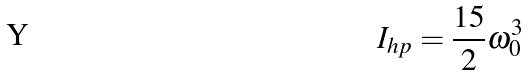Convert formula to latex. <formula><loc_0><loc_0><loc_500><loc_500>I _ { h p } = \frac { 1 5 } 2 \omega _ { 0 } ^ { 3 }</formula> 